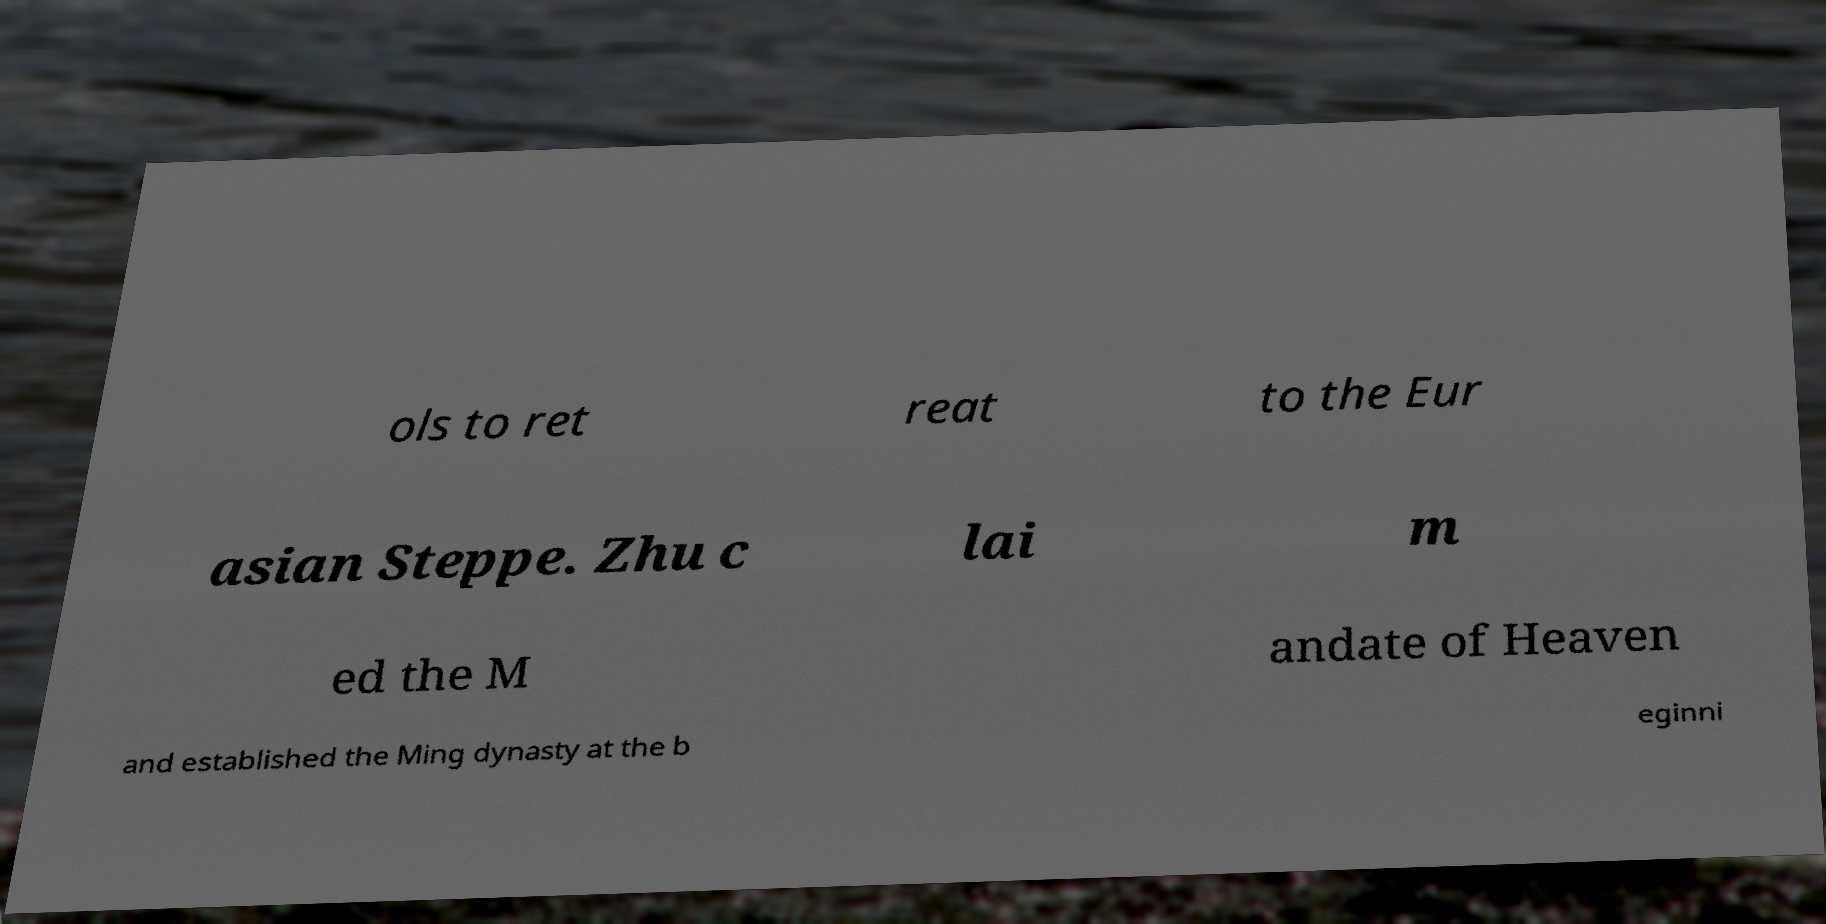There's text embedded in this image that I need extracted. Can you transcribe it verbatim? ols to ret reat to the Eur asian Steppe. Zhu c lai m ed the M andate of Heaven and established the Ming dynasty at the b eginni 